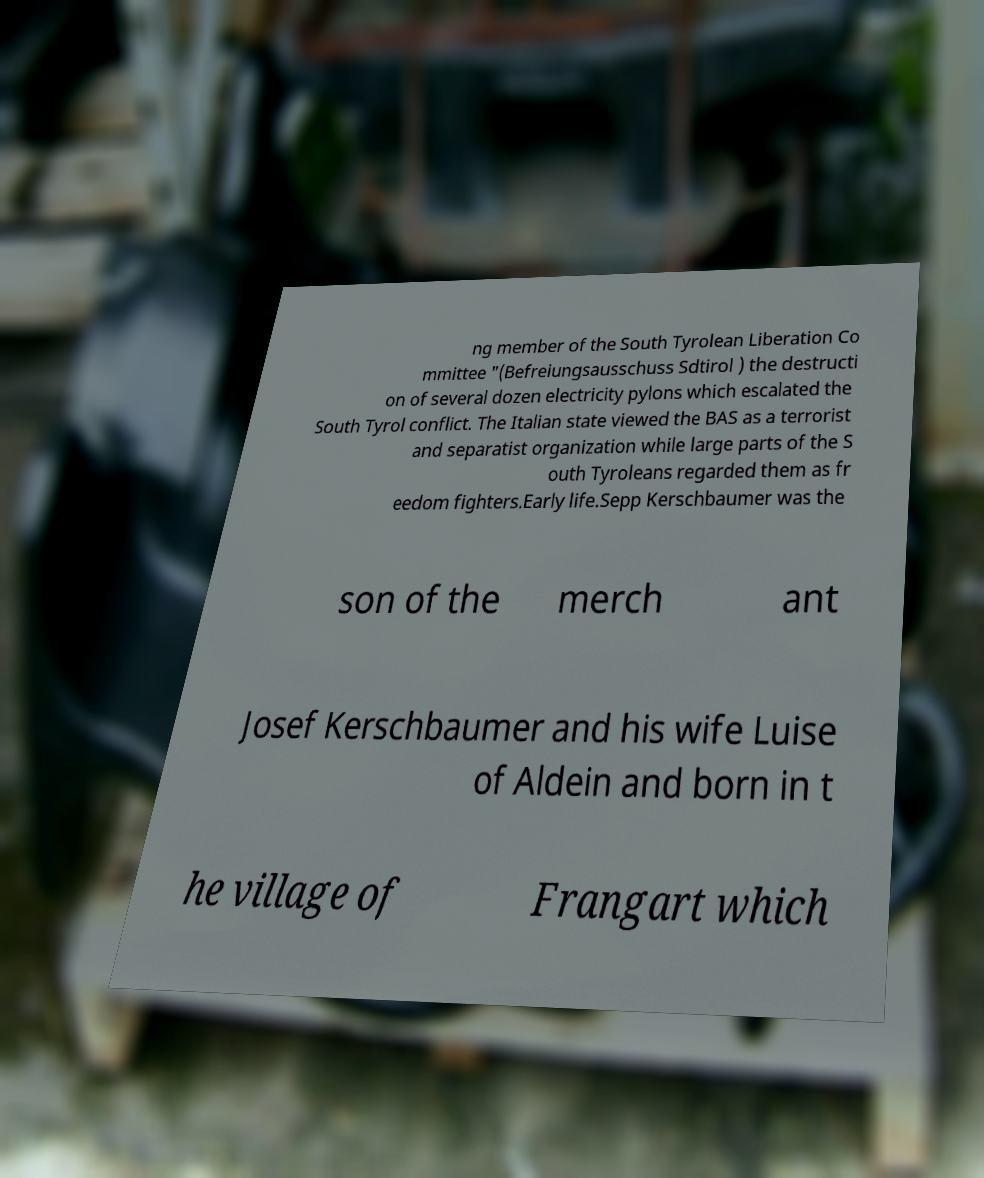For documentation purposes, I need the text within this image transcribed. Could you provide that? ng member of the South Tyrolean Liberation Co mmittee "(Befreiungsausschuss Sdtirol ) the destructi on of several dozen electricity pylons which escalated the South Tyrol conflict. The Italian state viewed the BAS as a terrorist and separatist organization while large parts of the S outh Tyroleans regarded them as fr eedom fighters.Early life.Sepp Kerschbaumer was the son of the merch ant Josef Kerschbaumer and his wife Luise of Aldein and born in t he village of Frangart which 